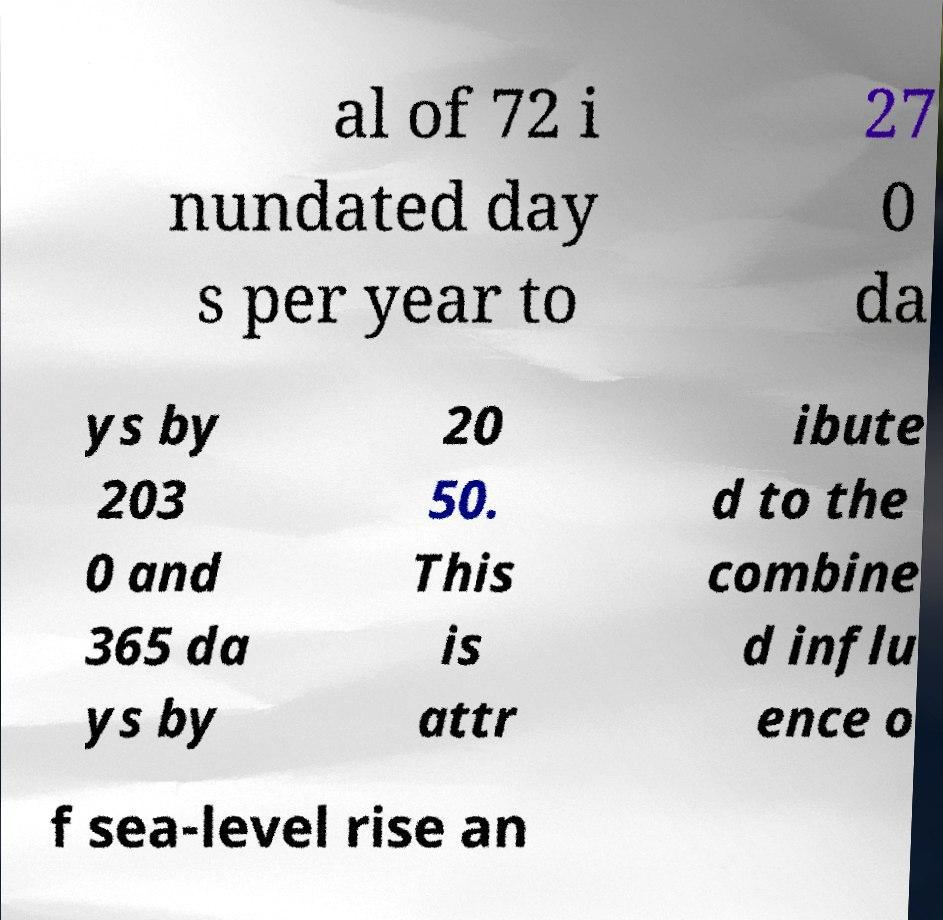Please identify and transcribe the text found in this image. al of 72 i nundated day s per year to 27 0 da ys by 203 0 and 365 da ys by 20 50. This is attr ibute d to the combine d influ ence o f sea-level rise an 